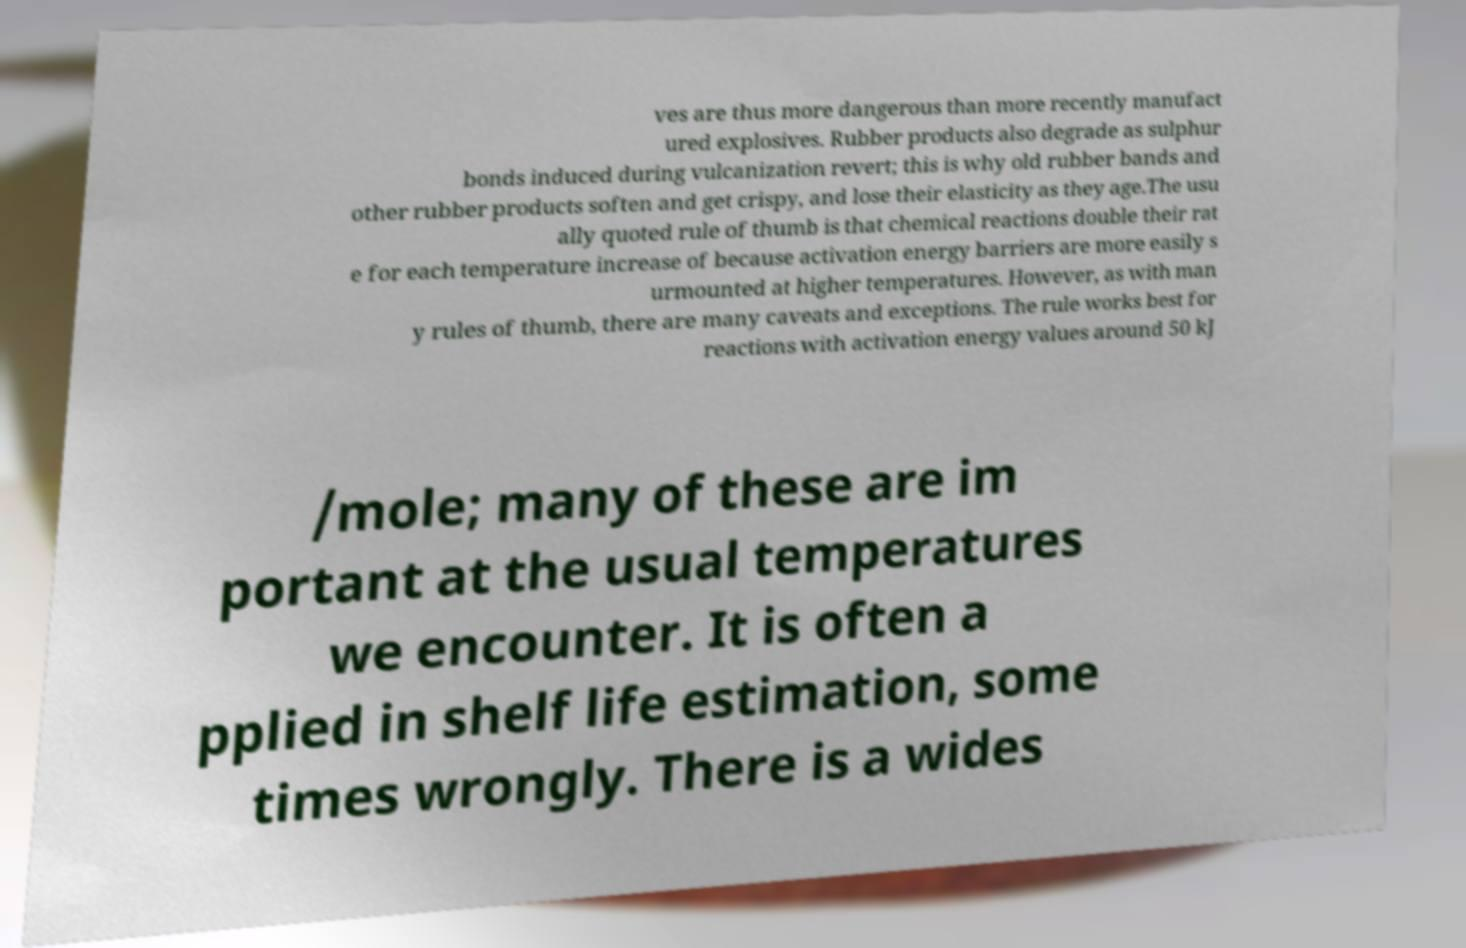Could you extract and type out the text from this image? ves are thus more dangerous than more recently manufact ured explosives. Rubber products also degrade as sulphur bonds induced during vulcanization revert; this is why old rubber bands and other rubber products soften and get crispy, and lose their elasticity as they age.The usu ally quoted rule of thumb is that chemical reactions double their rat e for each temperature increase of because activation energy barriers are more easily s urmounted at higher temperatures. However, as with man y rules of thumb, there are many caveats and exceptions. The rule works best for reactions with activation energy values around 50 kJ /mole; many of these are im portant at the usual temperatures we encounter. It is often a pplied in shelf life estimation, some times wrongly. There is a wides 